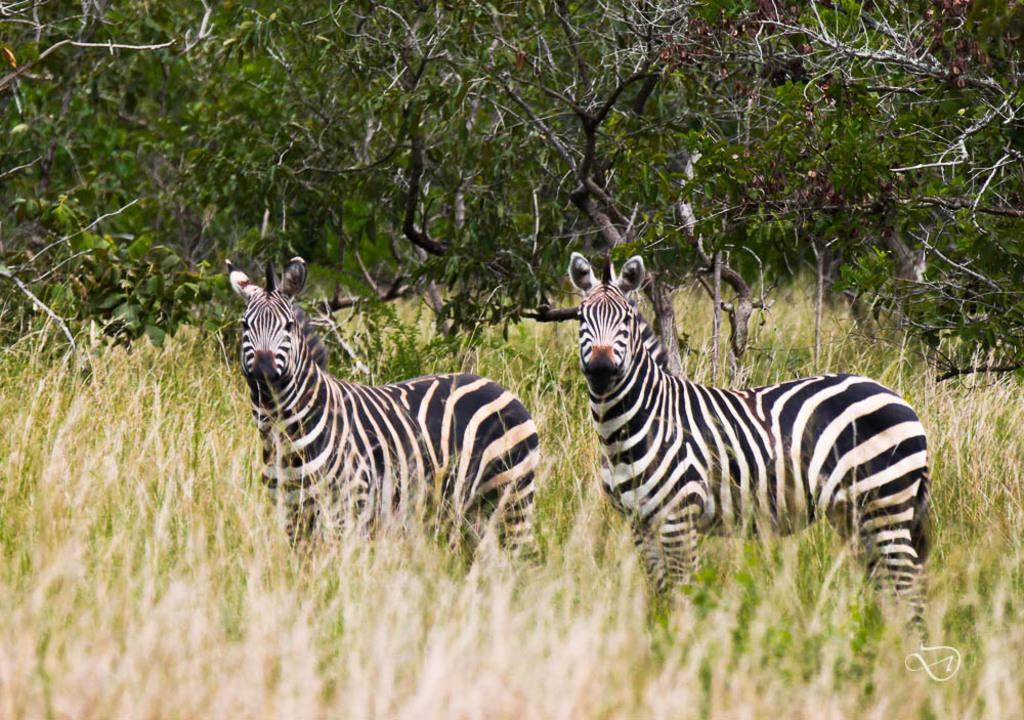What type of vegetation is present in the image? There are trees and grass in the image. What animals can be seen in the image? There are zebras in the middle of the image. What type of ornament is hanging from the trees in the image? There is no ornament hanging from the trees in the image; it only features trees, grass, and zebras. 